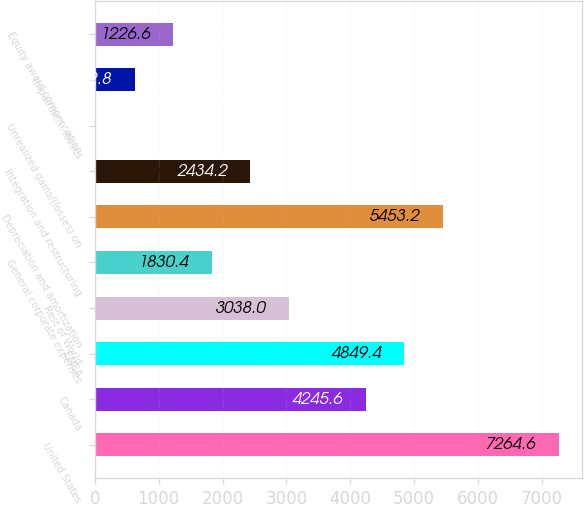<chart> <loc_0><loc_0><loc_500><loc_500><bar_chart><fcel>United States<fcel>Canada<fcel>EMEA<fcel>Rest of World<fcel>General corporate expenses<fcel>Depreciation and amortization<fcel>Integration and restructuring<fcel>Unrealized gains/(losses) on<fcel>Impairment losses<fcel>Equity award compensation<nl><fcel>7264.6<fcel>4245.6<fcel>4849.4<fcel>3038<fcel>1830.4<fcel>5453.2<fcel>2434.2<fcel>19<fcel>622.8<fcel>1226.6<nl></chart> 